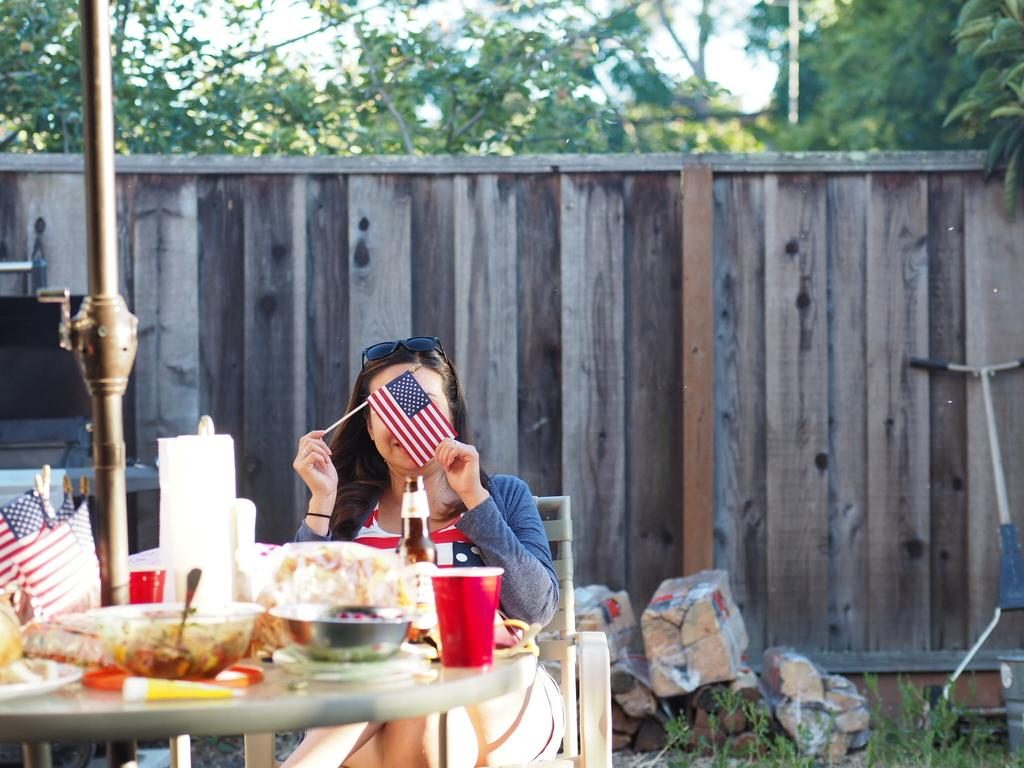What is the woman in the image holding? The woman is holding a flag in the image. What objects can be seen on the table in the image? There is a bowl and a glass on the table, along with additional items. What can be seen in the background of the image? There are trees, a stand, and a box in the background of the image. What type of birth can be seen taking place in the image? There is no birth taking place in the image; it features a woman holding a flag and objects on a table. What type of liquid is present in the glass on the table? The image does not provide information about the contents of the glass, so we cannot determine if there is any liquid present. 